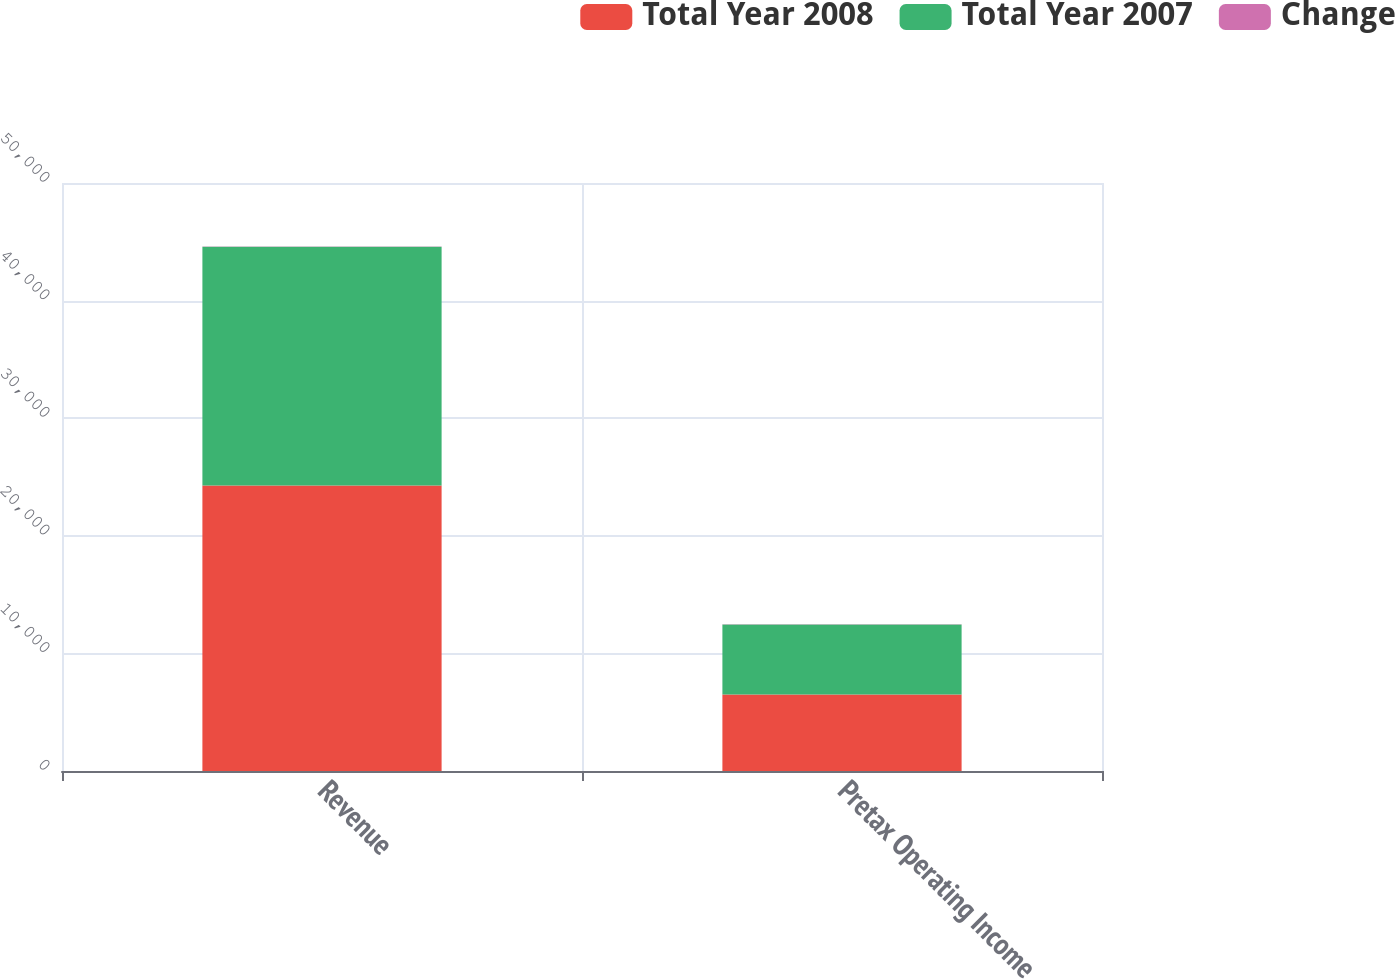Convert chart. <chart><loc_0><loc_0><loc_500><loc_500><stacked_bar_chart><ecel><fcel>Revenue<fcel>Pretax Operating Income<nl><fcel>Total Year 2008<fcel>24282<fcel>6505<nl><fcel>Total Year 2007<fcel>20306<fcel>5959<nl><fcel>Change<fcel>20<fcel>9<nl></chart> 